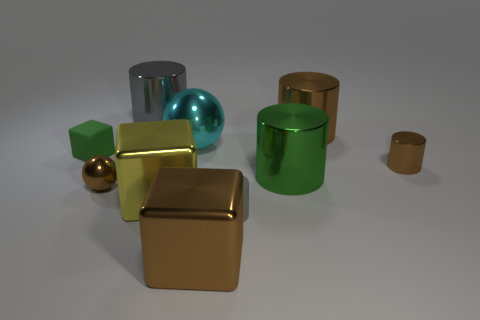Are any yellow matte cylinders visible?
Give a very brief answer. No. What size is the brown sphere that is the same material as the big yellow object?
Provide a short and direct response. Small. There is a gray thing left of the gray thing on the right side of the ball that is behind the tiny block; what shape is it?
Offer a very short reply. Cylinder. Are there the same number of small spheres behind the green rubber object and metal things?
Offer a terse response. No. What is the size of the shiny thing that is the same color as the matte cube?
Make the answer very short. Large. Is the large green object the same shape as the big gray object?
Provide a short and direct response. Yes. How many things are either brown metallic objects behind the small brown metallic sphere or big green cylinders?
Offer a terse response. 3. Are there the same number of brown shiny cylinders that are behind the large cyan metal thing and brown cubes on the left side of the small gray matte thing?
Ensure brevity in your answer.  Yes. How many other things are there of the same shape as the big yellow metallic thing?
Make the answer very short. 2. Is the size of the gray cylinder to the right of the large brown block the same as the brown cylinder that is in front of the matte block?
Give a very brief answer. Yes. 